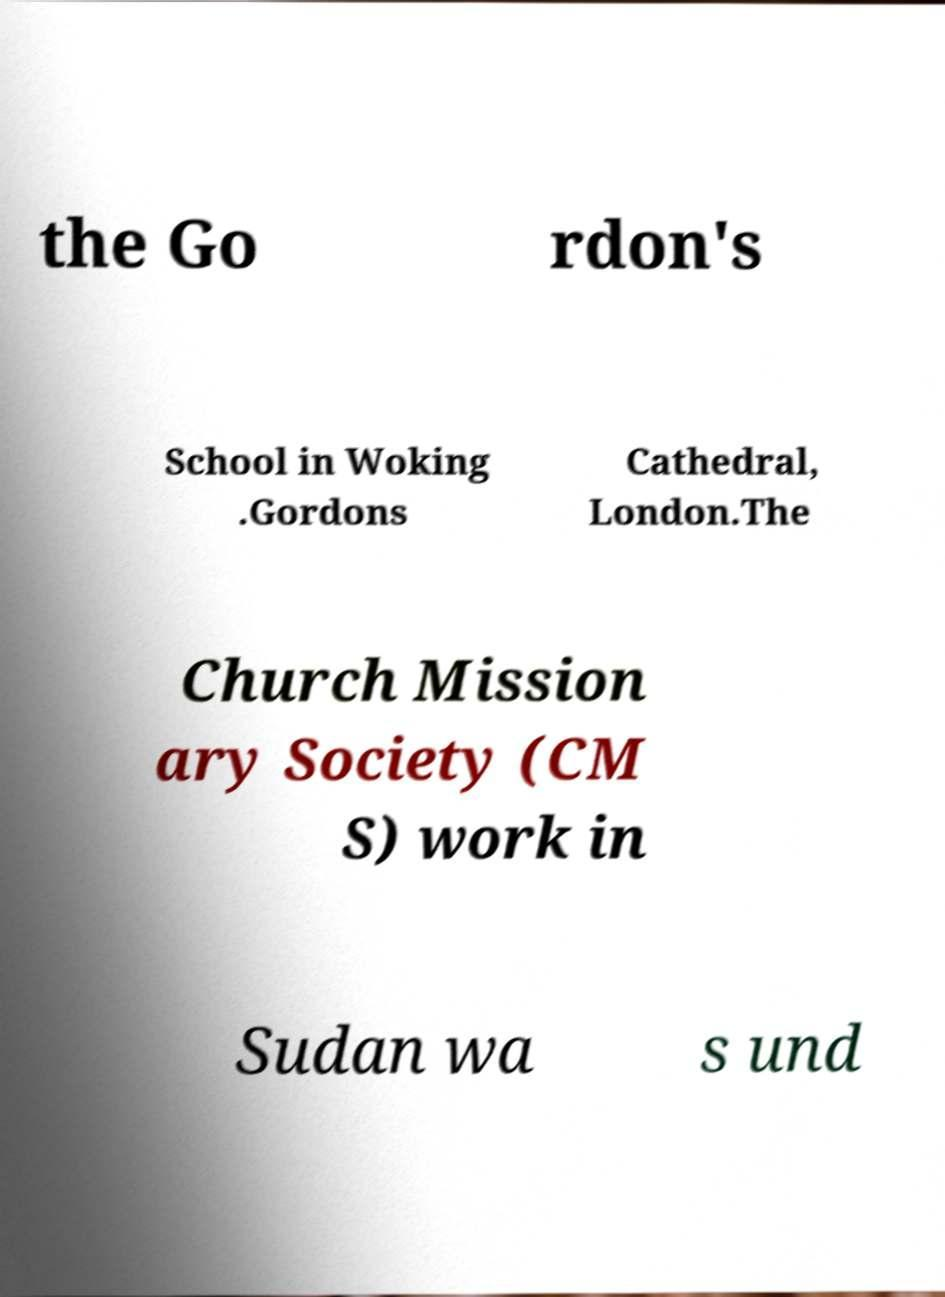I need the written content from this picture converted into text. Can you do that? the Go rdon's School in Woking .Gordons Cathedral, London.The Church Mission ary Society (CM S) work in Sudan wa s und 